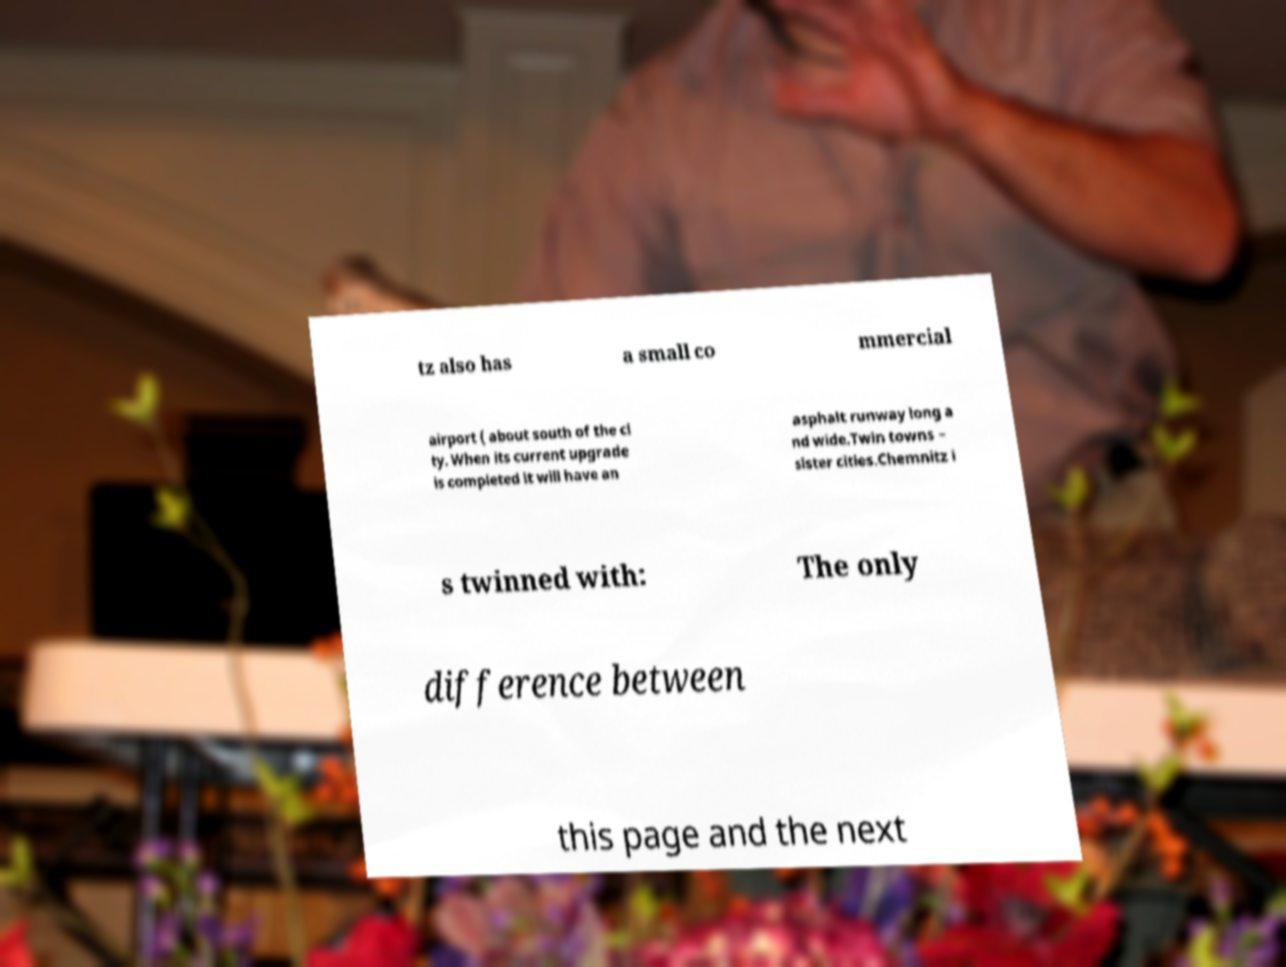Could you extract and type out the text from this image? tz also has a small co mmercial airport ( about south of the ci ty. When its current upgrade is completed it will have an asphalt runway long a nd wide.Twin towns – sister cities.Chemnitz i s twinned with: The only difference between this page and the next 